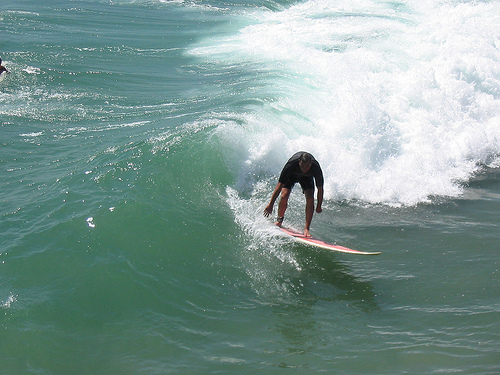Please provide the bounding box coordinate of the region this sentence describes: this is a wave. The bounding box for the wave region is [0.42, 0.33, 0.54, 0.46], capturing the upper part of the wave curling towards the shore. 